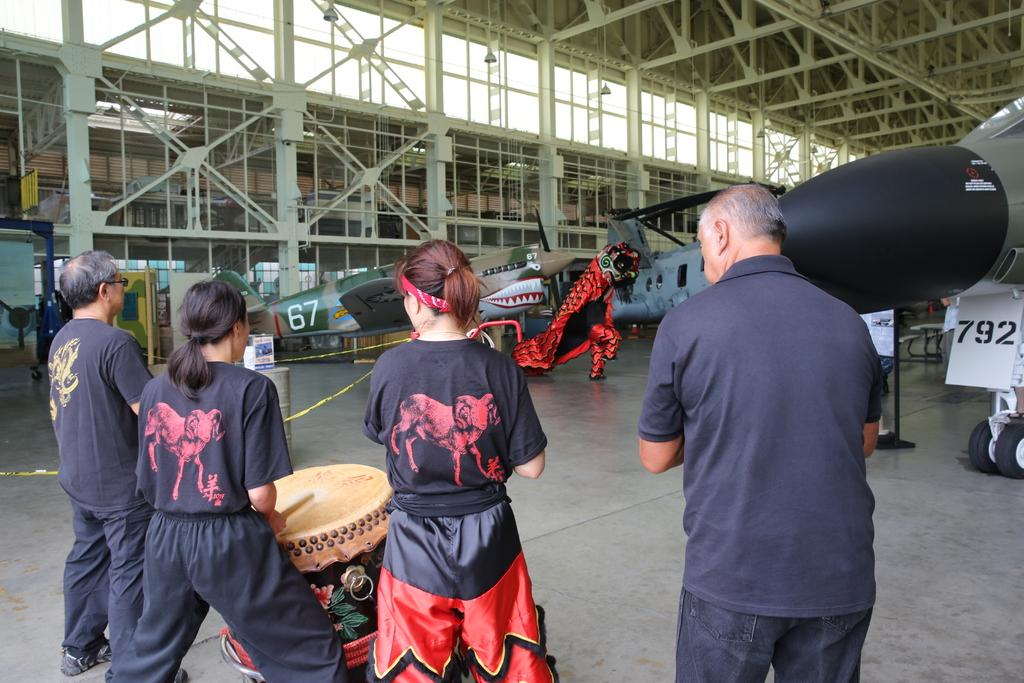How many people are present in the image? There are four persons standing in the image. What is one person doing in the image? One person is playing a musical drum. What type of vehicles can be seen in the image? There are aeroplanes in the image. What type of structure is present in the image? There is a shed in the image. What type of object can be seen with a red color in the image? There is a red-colored toy in the image. What type of hook can be seen holding the bread in the image? There is no hook or bread present in the image. What is the common interest among the four persons in the image? The provided facts do not mention any common interest among the four persons in the image. 